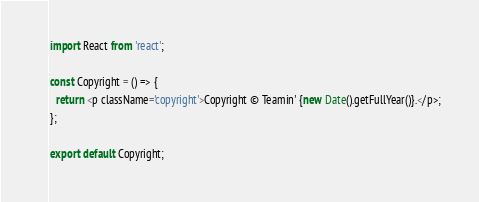Convert code to text. <code><loc_0><loc_0><loc_500><loc_500><_JavaScript_>import React from 'react';

const Copyright = () => {
  return <p className='copyright'>Copyright © Teamin' {new Date().getFullYear()}.</p>;
};

export default Copyright;
</code> 